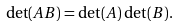Convert formula to latex. <formula><loc_0><loc_0><loc_500><loc_500>\det ( A B ) = \det ( A ) \, \det ( B ) .</formula> 